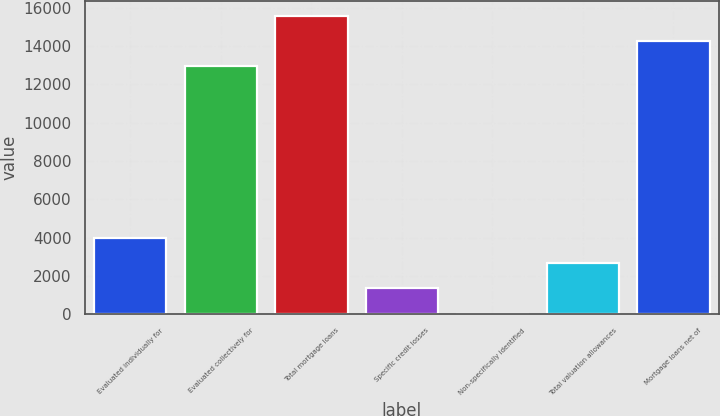Convert chart. <chart><loc_0><loc_0><loc_500><loc_500><bar_chart><fcel>Evaluated individually for<fcel>Evaluated collectively for<fcel>Total mortgage loans<fcel>Specific credit losses<fcel>Non-specifically identified<fcel>Total valuation allowances<fcel>Mortgage loans net of<nl><fcel>3963.9<fcel>12970<fcel>15588.6<fcel>1345.3<fcel>36<fcel>2654.6<fcel>14279.3<nl></chart> 